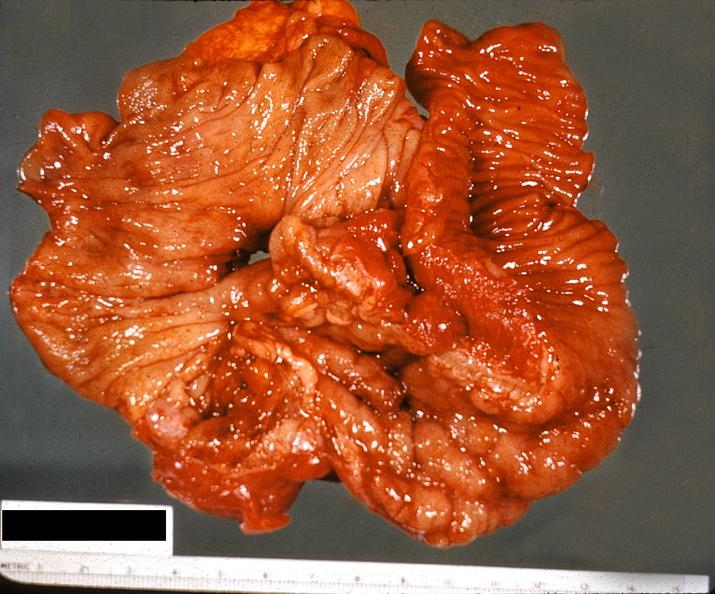what is present?
Answer the question using a single word or phrase. Gastrointestinal 